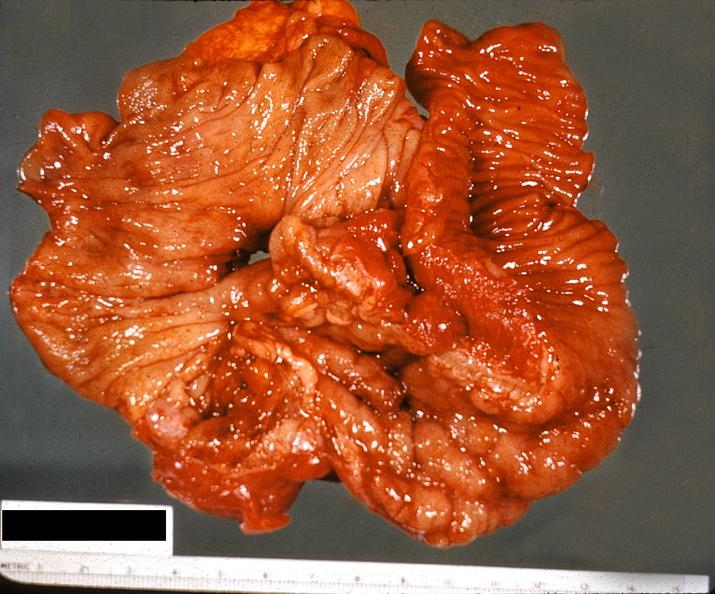what is present?
Answer the question using a single word or phrase. Gastrointestinal 